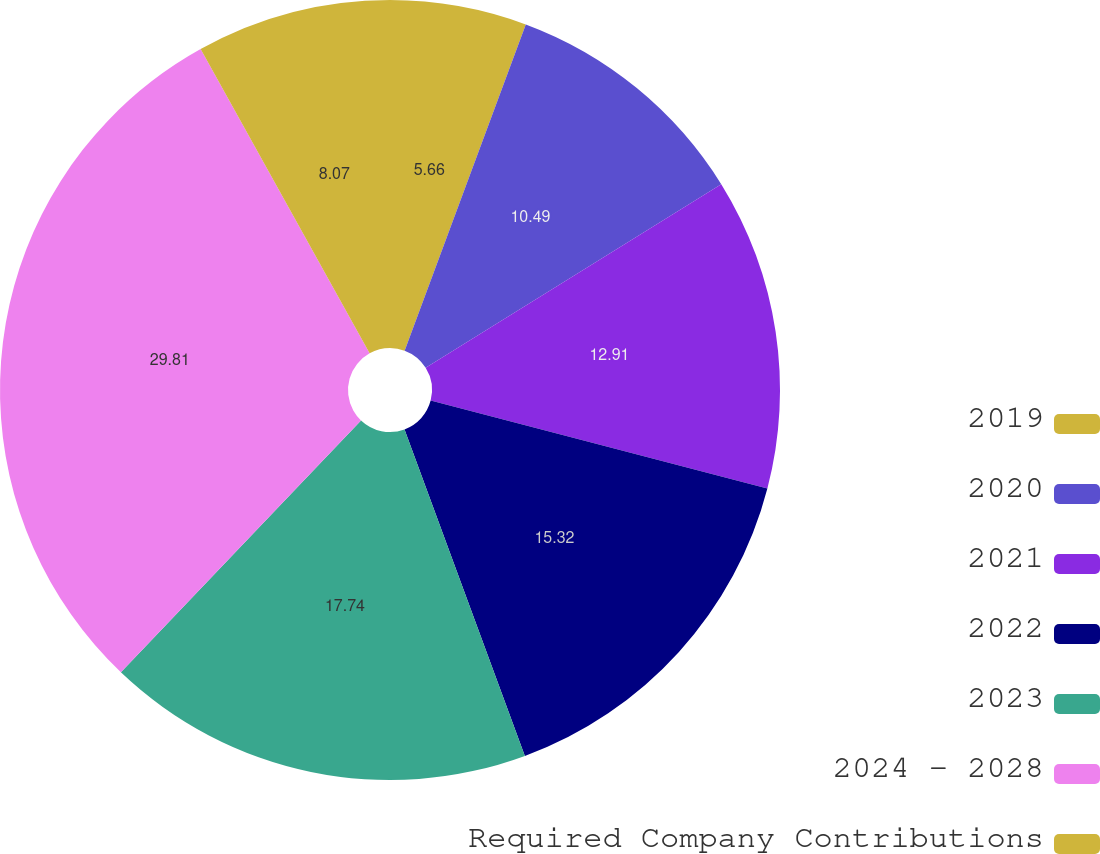<chart> <loc_0><loc_0><loc_500><loc_500><pie_chart><fcel>2019<fcel>2020<fcel>2021<fcel>2022<fcel>2023<fcel>2024 - 2028<fcel>Required Company Contributions<nl><fcel>5.66%<fcel>10.49%<fcel>12.91%<fcel>15.32%<fcel>17.74%<fcel>29.81%<fcel>8.07%<nl></chart> 